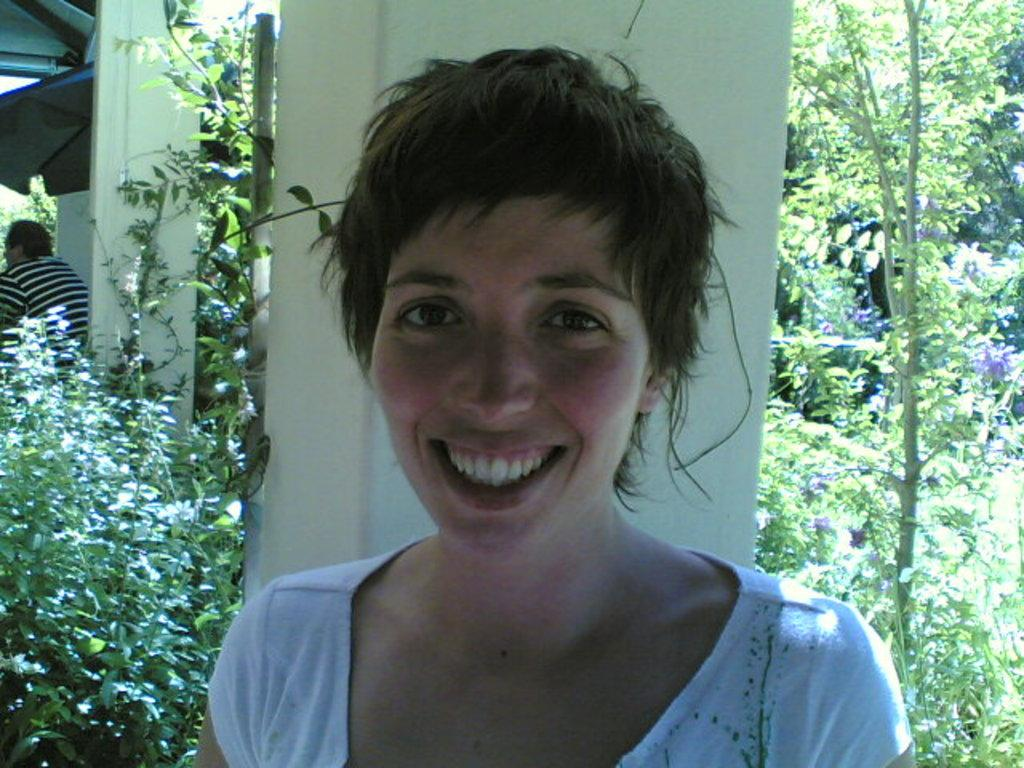Who is present in the image? There is a woman and a person in the image. What is the woman doing in the image? The woman is smiling in the image. What architectural features can be seen in the image? There are pillars and a roof top in the image. What type of natural elements are visible in the image? There are trees in the image. Can you see any goldfish swimming in the image? There are no goldfish present in the image. What type of rub is being used to clean the pillars in the image? There is no rubbing or cleaning activity depicted in the image, and no rub is mentioned. 